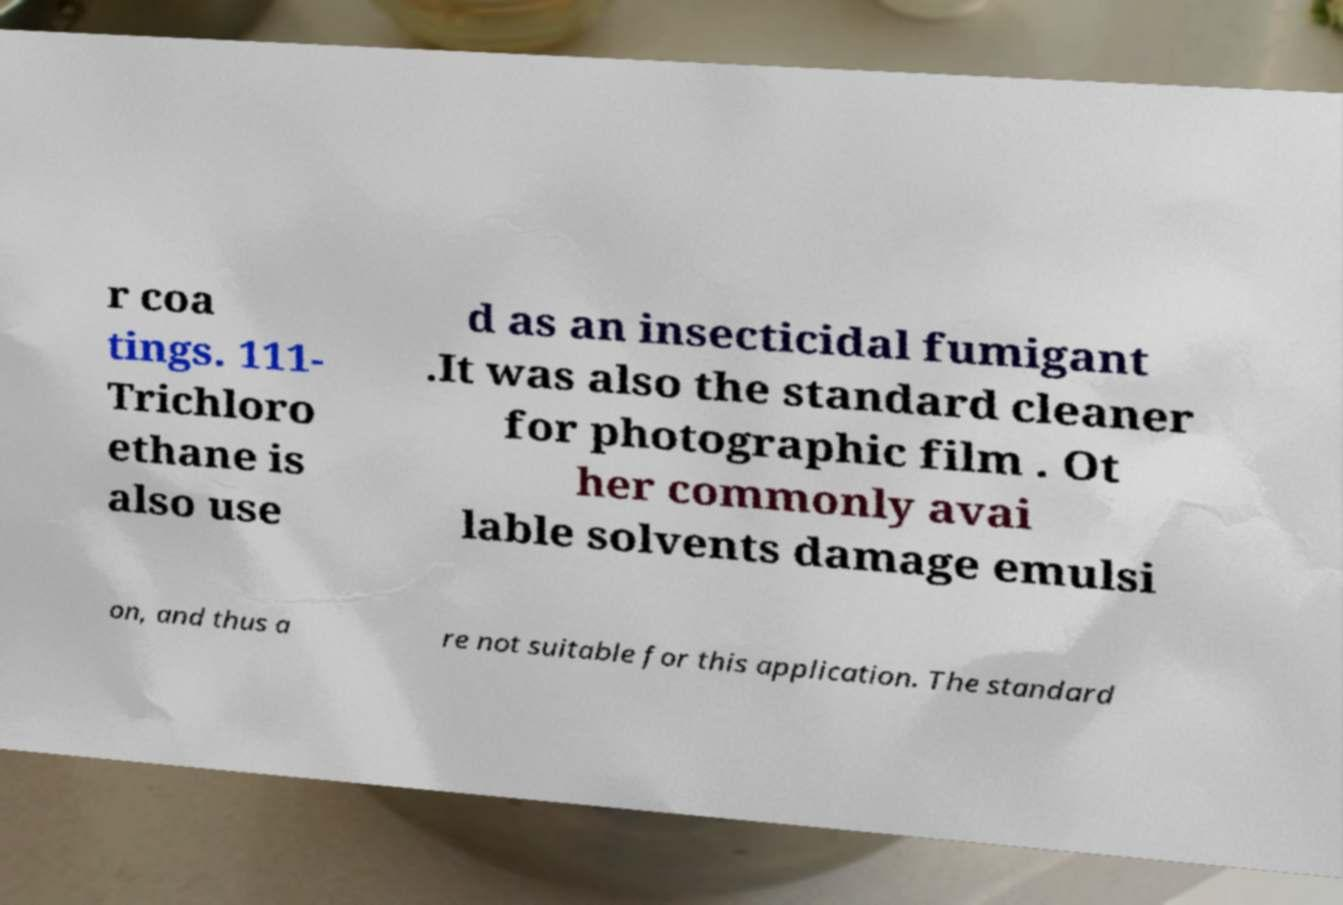What messages or text are displayed in this image? I need them in a readable, typed format. r coa tings. 111- Trichloro ethane is also use d as an insecticidal fumigant .It was also the standard cleaner for photographic film . Ot her commonly avai lable solvents damage emulsi on, and thus a re not suitable for this application. The standard 